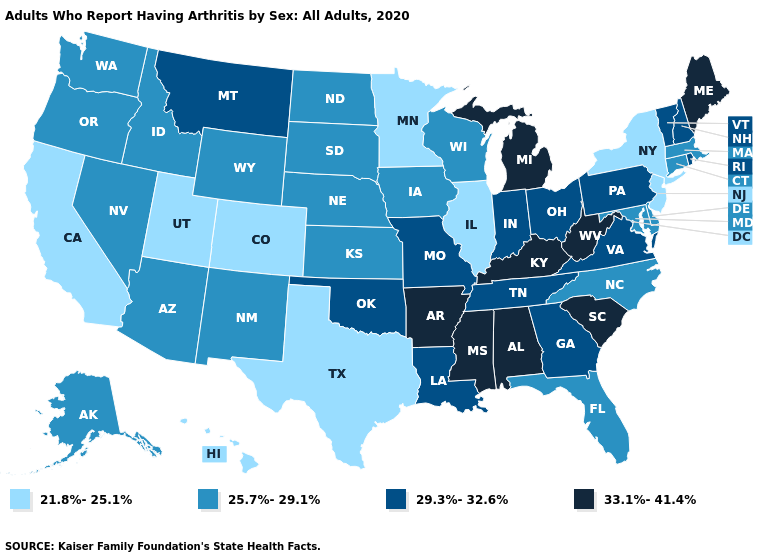What is the value of North Dakota?
Keep it brief. 25.7%-29.1%. What is the value of Vermont?
Write a very short answer. 29.3%-32.6%. Name the states that have a value in the range 25.7%-29.1%?
Short answer required. Alaska, Arizona, Connecticut, Delaware, Florida, Idaho, Iowa, Kansas, Maryland, Massachusetts, Nebraska, Nevada, New Mexico, North Carolina, North Dakota, Oregon, South Dakota, Washington, Wisconsin, Wyoming. Which states have the lowest value in the South?
Give a very brief answer. Texas. How many symbols are there in the legend?
Answer briefly. 4. Is the legend a continuous bar?
Be succinct. No. What is the value of Nebraska?
Short answer required. 25.7%-29.1%. What is the highest value in the South ?
Keep it brief. 33.1%-41.4%. What is the lowest value in the USA?
Answer briefly. 21.8%-25.1%. What is the lowest value in states that border South Carolina?
Be succinct. 25.7%-29.1%. Name the states that have a value in the range 33.1%-41.4%?
Answer briefly. Alabama, Arkansas, Kentucky, Maine, Michigan, Mississippi, South Carolina, West Virginia. Name the states that have a value in the range 29.3%-32.6%?
Keep it brief. Georgia, Indiana, Louisiana, Missouri, Montana, New Hampshire, Ohio, Oklahoma, Pennsylvania, Rhode Island, Tennessee, Vermont, Virginia. Name the states that have a value in the range 25.7%-29.1%?
Short answer required. Alaska, Arizona, Connecticut, Delaware, Florida, Idaho, Iowa, Kansas, Maryland, Massachusetts, Nebraska, Nevada, New Mexico, North Carolina, North Dakota, Oregon, South Dakota, Washington, Wisconsin, Wyoming. What is the value of Vermont?
Answer briefly. 29.3%-32.6%. Name the states that have a value in the range 33.1%-41.4%?
Answer briefly. Alabama, Arkansas, Kentucky, Maine, Michigan, Mississippi, South Carolina, West Virginia. 